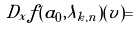Convert formula to latex. <formula><loc_0><loc_0><loc_500><loc_500>D _ { x } f ( a _ { 0 } , \lambda _ { k , n } ) ( v ) =</formula> 